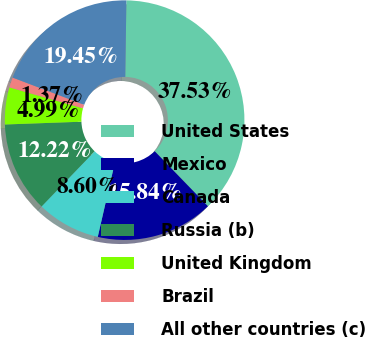Convert chart. <chart><loc_0><loc_0><loc_500><loc_500><pie_chart><fcel>United States<fcel>Mexico<fcel>Canada<fcel>Russia (b)<fcel>United Kingdom<fcel>Brazil<fcel>All other countries (c)<nl><fcel>37.53%<fcel>15.84%<fcel>8.6%<fcel>12.22%<fcel>4.99%<fcel>1.37%<fcel>19.45%<nl></chart> 